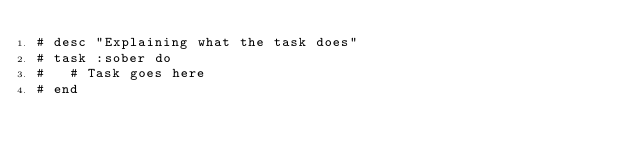<code> <loc_0><loc_0><loc_500><loc_500><_Ruby_># desc "Explaining what the task does"
# task :sober do
#   # Task goes here
# end
</code> 